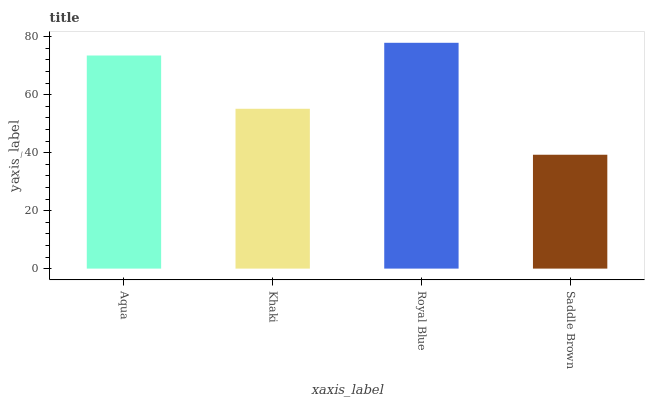Is Saddle Brown the minimum?
Answer yes or no. Yes. Is Royal Blue the maximum?
Answer yes or no. Yes. Is Khaki the minimum?
Answer yes or no. No. Is Khaki the maximum?
Answer yes or no. No. Is Aqua greater than Khaki?
Answer yes or no. Yes. Is Khaki less than Aqua?
Answer yes or no. Yes. Is Khaki greater than Aqua?
Answer yes or no. No. Is Aqua less than Khaki?
Answer yes or no. No. Is Aqua the high median?
Answer yes or no. Yes. Is Khaki the low median?
Answer yes or no. Yes. Is Khaki the high median?
Answer yes or no. No. Is Saddle Brown the low median?
Answer yes or no. No. 